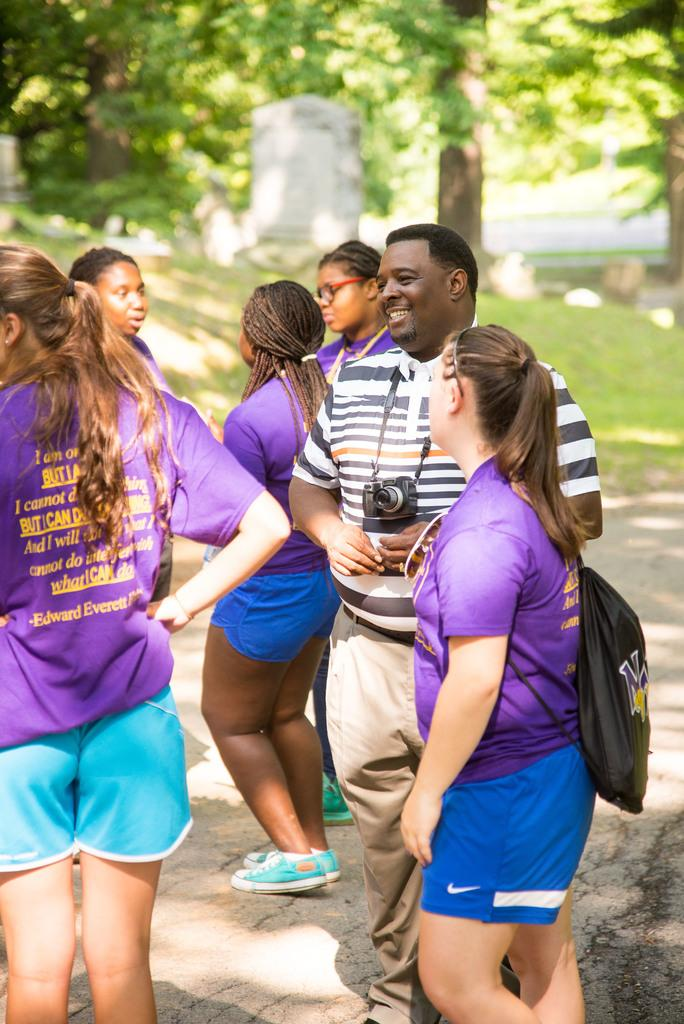How many people are present in the image? There are six people in the image. What are two of the people carrying? One person is carrying a camera, and another person is carrying a bag. What type of natural environment is visible in the image? There are trees and grass visible in the image. What type of mint can be seen growing near the trees in the image? There is no mint visible in the image; only trees and grass are present. 